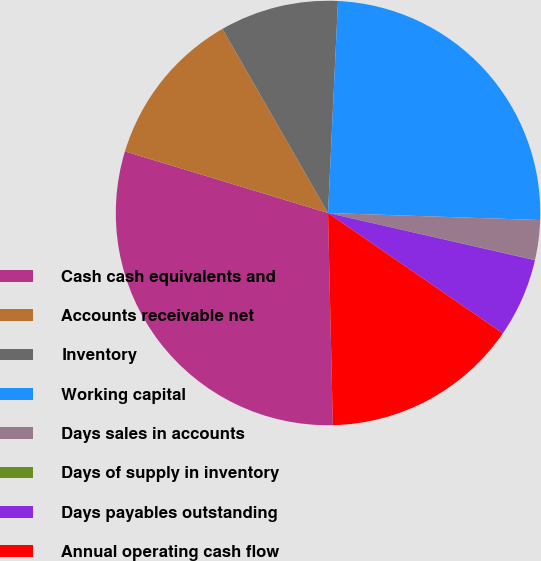Convert chart to OTSL. <chart><loc_0><loc_0><loc_500><loc_500><pie_chart><fcel>Cash cash equivalents and<fcel>Accounts receivable net<fcel>Inventory<fcel>Working capital<fcel>Days sales in accounts<fcel>Days of supply in inventory<fcel>Days payables outstanding<fcel>Annual operating cash flow<nl><fcel>30.05%<fcel>12.03%<fcel>9.03%<fcel>24.78%<fcel>3.02%<fcel>0.02%<fcel>6.03%<fcel>15.04%<nl></chart> 